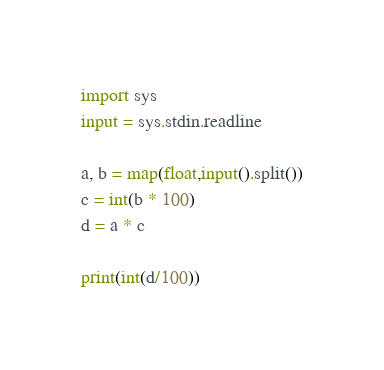<code> <loc_0><loc_0><loc_500><loc_500><_Python_>import sys
input = sys.stdin.readline

a, b = map(float,input().split())
c = int(b * 100)
d = a * c

print(int(d/100))</code> 